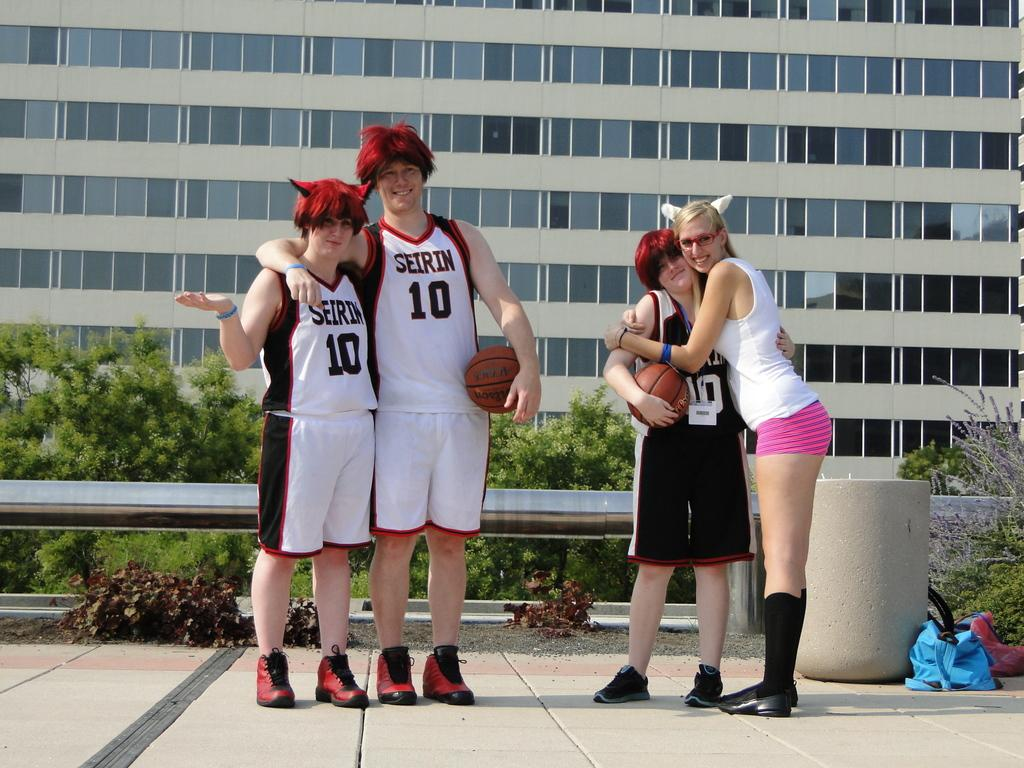<image>
Describe the image concisely. Two people in Seirin jerseys stand wearing fuzzy wigs. 